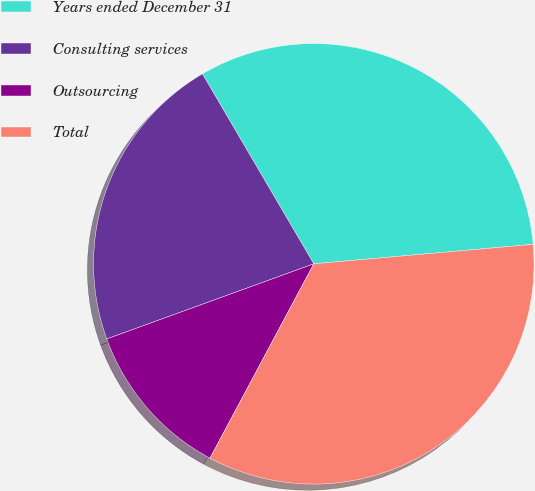Convert chart. <chart><loc_0><loc_0><loc_500><loc_500><pie_chart><fcel>Years ended December 31<fcel>Consulting services<fcel>Outsourcing<fcel>Total<nl><fcel>32.03%<fcel>22.1%<fcel>11.65%<fcel>34.22%<nl></chart> 